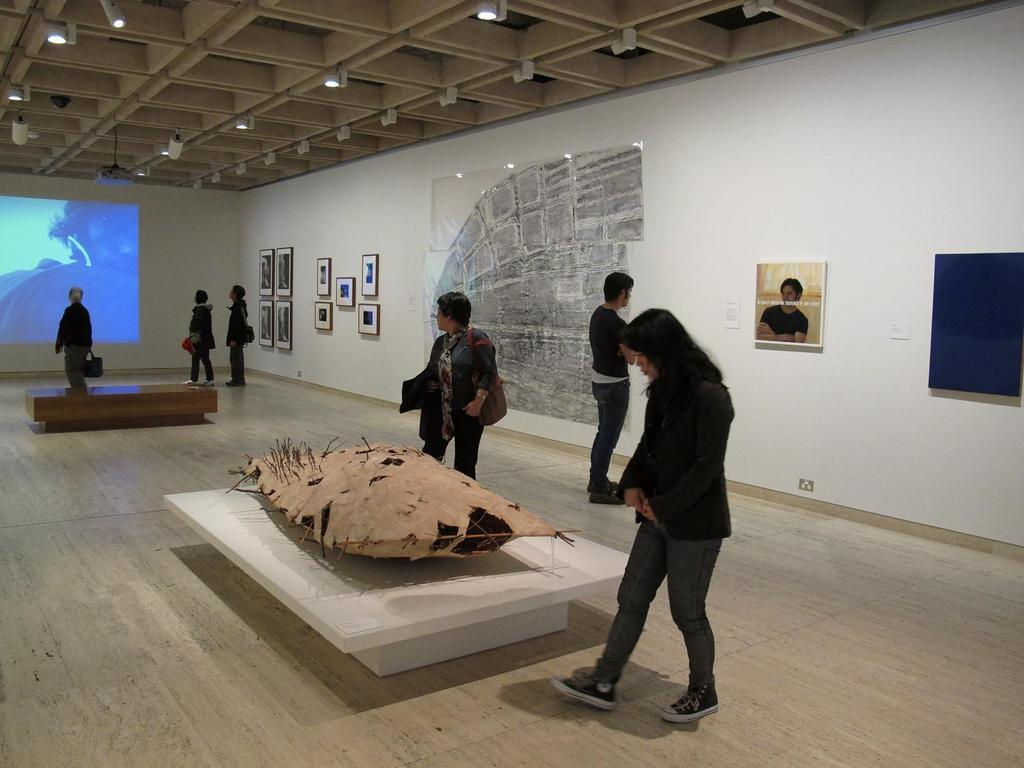What can be seen on the wall in the image? There are photo frames on the wall in the image. What are the people in the image doing? There are people walking in the image. What objects can be seen on tables in the image? There are things on tables in the image, but the specific objects are not mentioned in the facts. Can you tell me the weight of the plane visible in the image? There is no plane present in the image. What type of collar is being worn by the people walking in the image? The facts do not mention any collars being worn by the people in the image. 